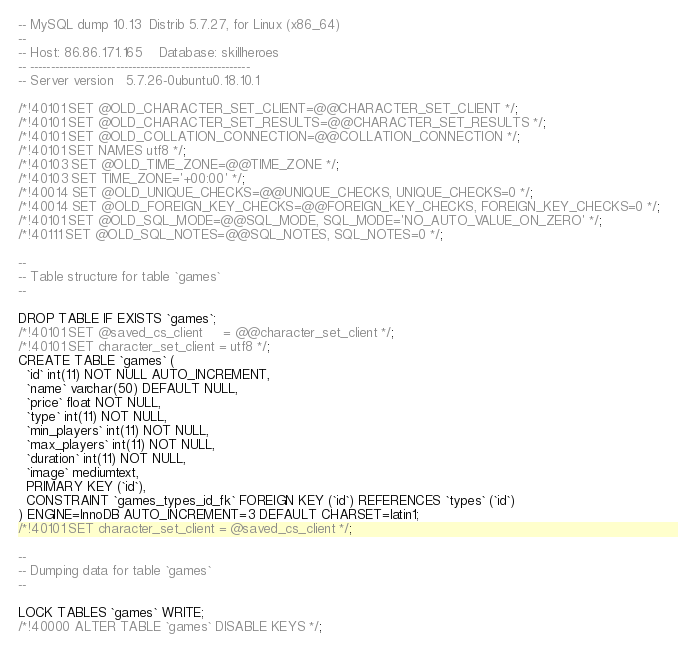Convert code to text. <code><loc_0><loc_0><loc_500><loc_500><_SQL_>-- MySQL dump 10.13  Distrib 5.7.27, for Linux (x86_64)
--
-- Host: 86.86.171.165    Database: skillheroes
-- ------------------------------------------------------
-- Server version	5.7.26-0ubuntu0.18.10.1

/*!40101 SET @OLD_CHARACTER_SET_CLIENT=@@CHARACTER_SET_CLIENT */;
/*!40101 SET @OLD_CHARACTER_SET_RESULTS=@@CHARACTER_SET_RESULTS */;
/*!40101 SET @OLD_COLLATION_CONNECTION=@@COLLATION_CONNECTION */;
/*!40101 SET NAMES utf8 */;
/*!40103 SET @OLD_TIME_ZONE=@@TIME_ZONE */;
/*!40103 SET TIME_ZONE='+00:00' */;
/*!40014 SET @OLD_UNIQUE_CHECKS=@@UNIQUE_CHECKS, UNIQUE_CHECKS=0 */;
/*!40014 SET @OLD_FOREIGN_KEY_CHECKS=@@FOREIGN_KEY_CHECKS, FOREIGN_KEY_CHECKS=0 */;
/*!40101 SET @OLD_SQL_MODE=@@SQL_MODE, SQL_MODE='NO_AUTO_VALUE_ON_ZERO' */;
/*!40111 SET @OLD_SQL_NOTES=@@SQL_NOTES, SQL_NOTES=0 */;

--
-- Table structure for table `games`
--

DROP TABLE IF EXISTS `games`;
/*!40101 SET @saved_cs_client     = @@character_set_client */;
/*!40101 SET character_set_client = utf8 */;
CREATE TABLE `games` (
  `id` int(11) NOT NULL AUTO_INCREMENT,
  `name` varchar(50) DEFAULT NULL,
  `price` float NOT NULL,
  `type` int(11) NOT NULL,
  `min_players` int(11) NOT NULL,
  `max_players` int(11) NOT NULL,
  `duration` int(11) NOT NULL,
  `image` mediumtext,
  PRIMARY KEY (`id`),
  CONSTRAINT `games_types_id_fk` FOREIGN KEY (`id`) REFERENCES `types` (`id`)
) ENGINE=InnoDB AUTO_INCREMENT=3 DEFAULT CHARSET=latin1;
/*!40101 SET character_set_client = @saved_cs_client */;

--
-- Dumping data for table `games`
--

LOCK TABLES `games` WRITE;
/*!40000 ALTER TABLE `games` DISABLE KEYS */;</code> 